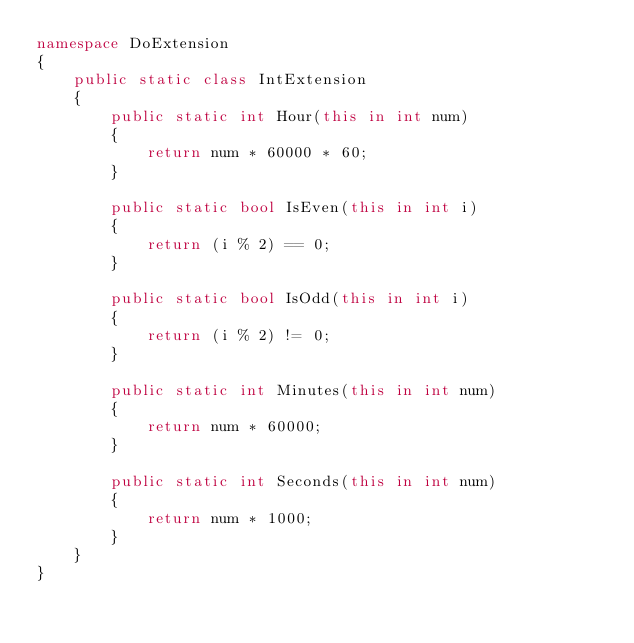<code> <loc_0><loc_0><loc_500><loc_500><_C#_>namespace DoExtension
{
    public static class IntExtension
    {
        public static int Hour(this in int num)
        {
            return num * 60000 * 60;
        }

        public static bool IsEven(this in int i)
        {
            return (i % 2) == 0;
        }

        public static bool IsOdd(this in int i)
        {
            return (i % 2) != 0;
        }

        public static int Minutes(this in int num)
        {
            return num * 60000;
        }

        public static int Seconds(this in int num)
        {
            return num * 1000;
        }
    }
}
</code> 